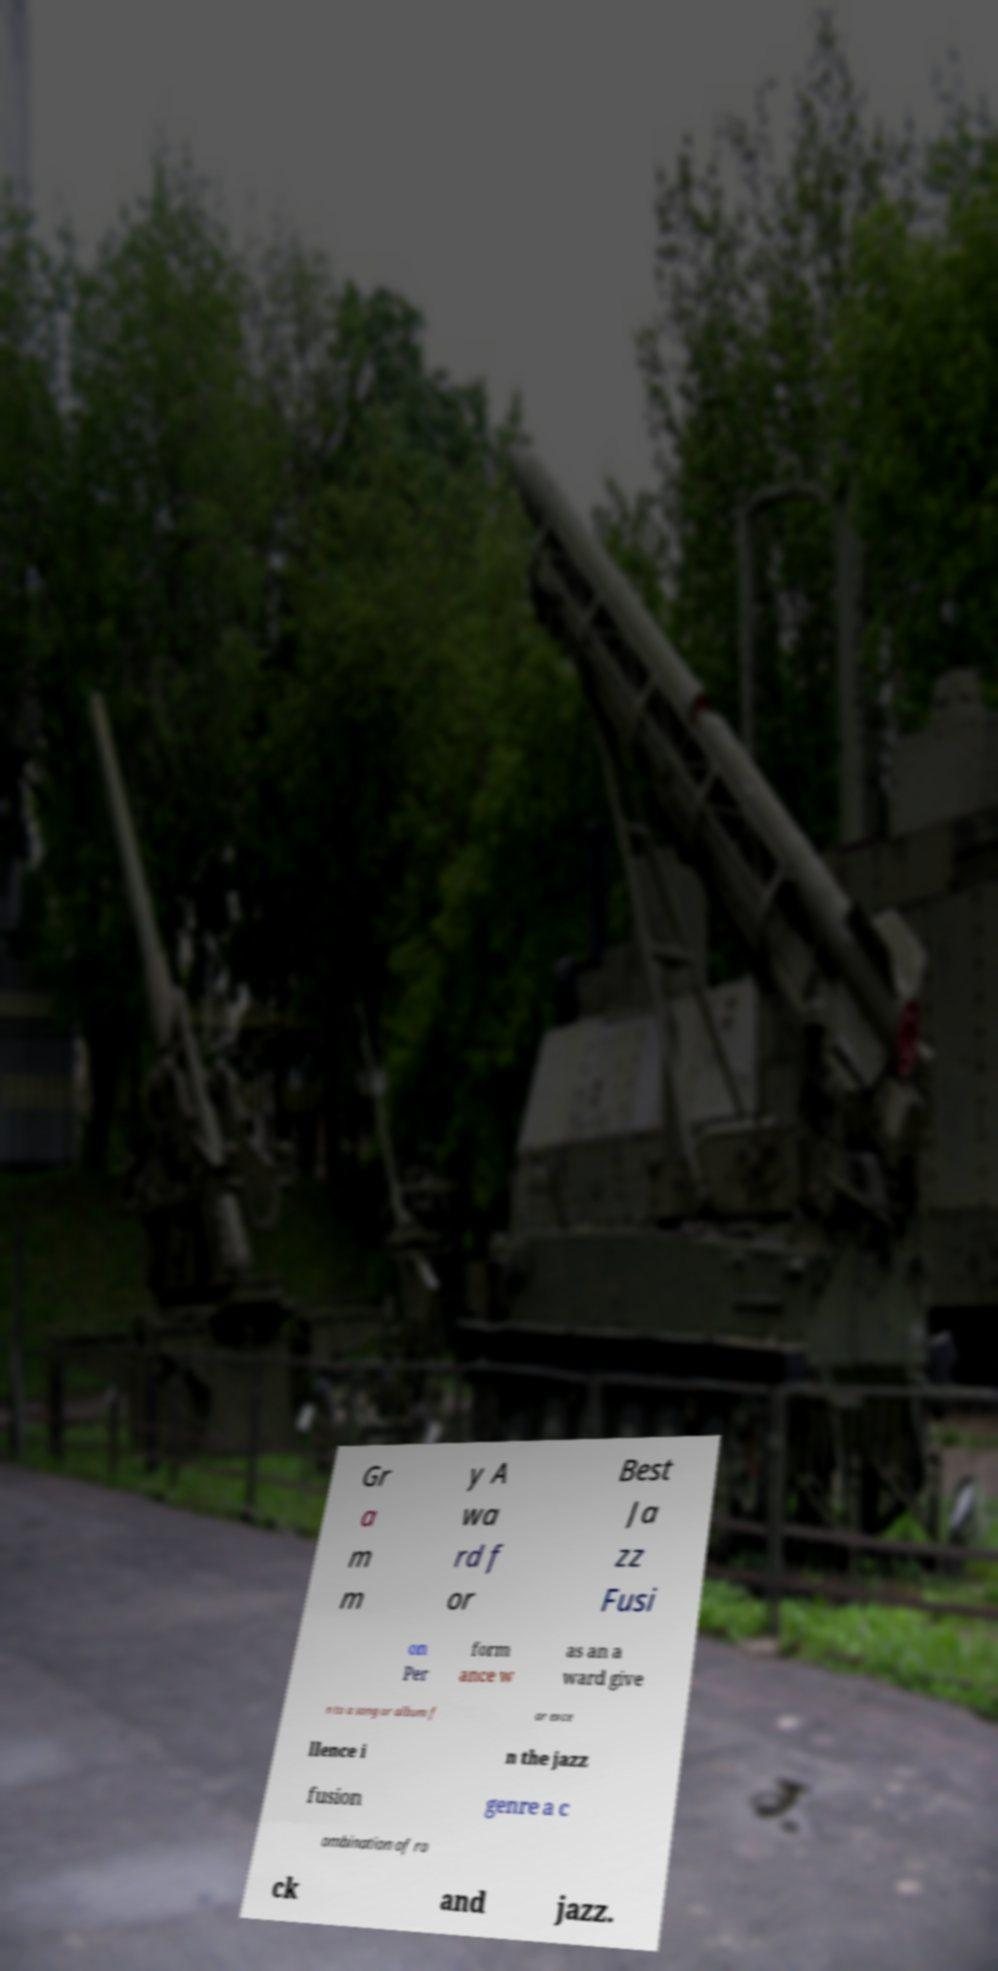There's text embedded in this image that I need extracted. Can you transcribe it verbatim? Gr a m m y A wa rd f or Best Ja zz Fusi on Per form ance w as an a ward give n to a song or album f or exce llence i n the jazz fusion genre a c ombination of ro ck and jazz. 